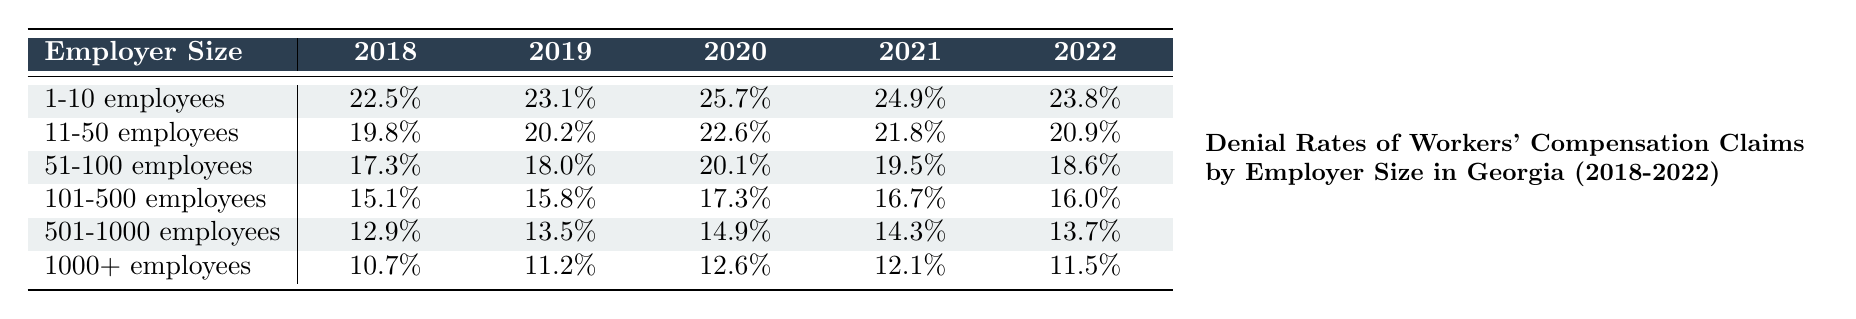What was the denial rate for the category "1-10 employees" in 2020? The table shows that in the year 2020, the denial rate for "1-10 employees" is 25.7%.
Answer: 25.7% Which employer size category had the lowest denial rate in 2022? In 2022, the employer size category "1000+ employees" had the lowest denial rate at 11.5%.
Answer: 11.5% What is the difference in denial rates between "501-1000 employees" and "1-10 employees" in 2019? In 2019, the denial rate for "501-1000 employees" is 13.5%, and for "1-10 employees," it is 23.1%. The difference is 23.1% - 13.5% = 9.6%.
Answer: 9.6% Did the denial rate for "101-500 employees" increase or decrease from 2018 to 2022? In 2018, the denial rate for "101-500 employees" was 15.1%, and in 2022 it was 16.0%. Since 16.0% is greater than 15.1%, it indicates an increase.
Answer: Increase What trend can be observed in the denial rates for "51-100 employees" from 2018 to 2022? The denial rates for "51-100 employees" decreased from 17.3% in 2018 to 18.6% in 2022, with a peak in 2020 at 20.1%. Thus, the trend shows an overall decrease in denial rates over these years.
Answer: Decrease overall with a peak in 2020 What was the average denial rate for all employer size categories in 2021? To find the average denial rate for 2021, we add the rates: (24.9 + 21.8 + 19.5 + 16.7 + 14.3 + 12.1) = 109.3%, then divide by 6, resulting in an average of 18.22%.
Answer: 18.22% If the denial rate for "11-50 employees" in 2020 is 22.6%, how does it compare to the rate for "1000+ employees"? In 2020, the denial rate for "1000+ employees" is 12.6%. Since 22.6% is greater than 12.6%, the "11-50 employees" category has a higher denial rate compared to "1000+ employees."
Answer: Higher What is the overall trend in denial rates for "1-10 employees" from 2018 to 2022? The denial rates for "1-10 employees" increased from 22.5% in 2018 to 23.8% in 2022, with a peak in 2020 at 25.7%. The trend shows an overall increase over these years.
Answer: Overall increase 